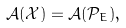<formula> <loc_0><loc_0><loc_500><loc_500>\mathcal { A } ( \mathcal { X } ) = \mathcal { A } ( \mathcal { P } _ { E } ) ,</formula> 